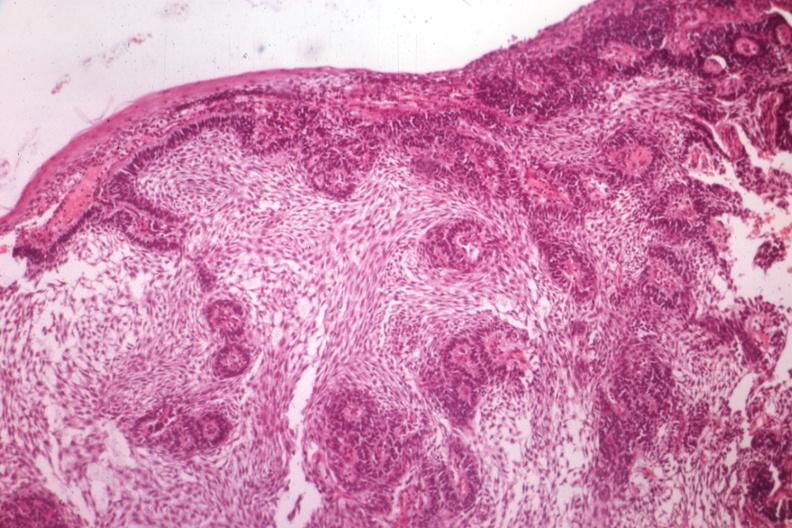what is a guess?
Answer the question using a single word or phrase. The unknown origin in mandible 